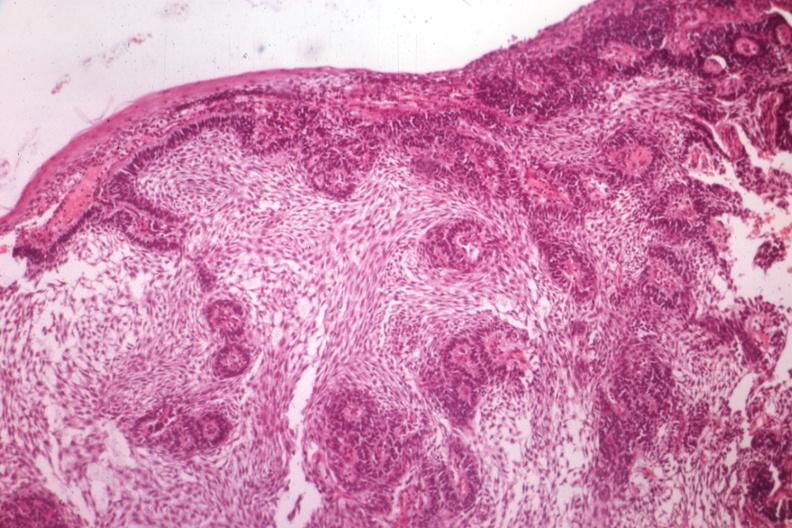what is a guess?
Answer the question using a single word or phrase. The unknown origin in mandible 